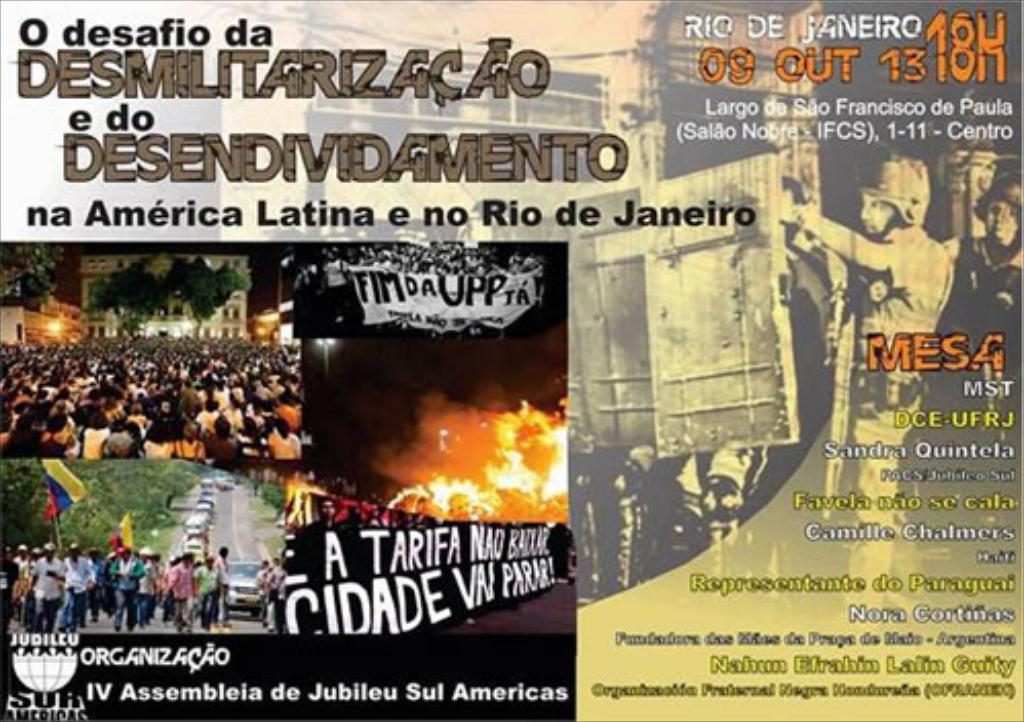Can you elaborate on the phrases such as 'FIM DA UPP' and 'CIDADE NÃO VAI PARAR' seen on the poster? What do they signify? 'FIM DA UPP' translates to 'End of the Pacifying Police Units,' indicating opposition to this particular public security policy in Rio de Janeiro. 'CIDADE NÃO VAI PARAR' means 'The city will not stop,' suggesting a relentless drive for change and resistance against the status quo by the protesting population. 